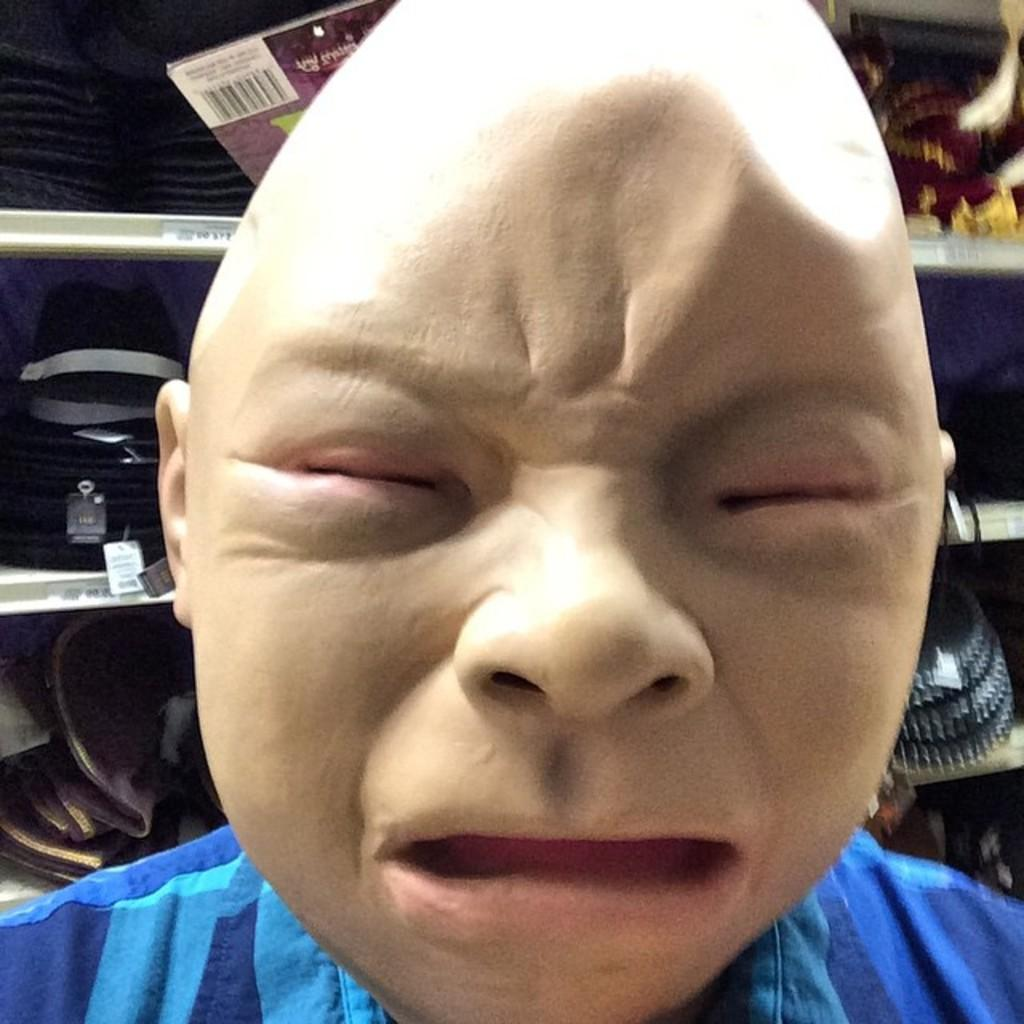What is the person in the image wearing on their face? The person in the image is wearing a mask. What can be seen in the background of the image? There is a rack in the background of the image. What is stored on the rack? There are products kept in the rack. What type of coal is being transported by the animal on the train in the image? There is no coal, animal, or train present in the image. 